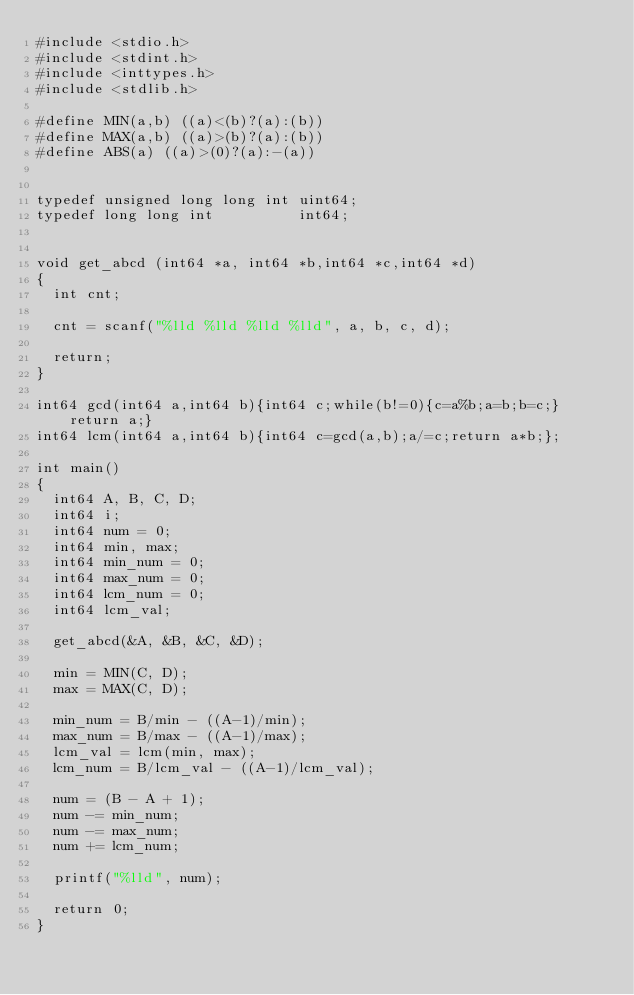<code> <loc_0><loc_0><loc_500><loc_500><_C_>#include <stdio.h>
#include <stdint.h>
#include <inttypes.h>
#include <stdlib.h>

#define MIN(a,b) ((a)<(b)?(a):(b))
#define MAX(a,b) ((a)>(b)?(a):(b))
#define ABS(a) ((a)>(0)?(a):-(a))


typedef unsigned long long int uint64;
typedef long long int          int64;


void get_abcd (int64 *a, int64 *b,int64 *c,int64 *d)
{
  int cnt;
  
  cnt = scanf("%lld %lld %lld %lld", a, b, c, d);

  return;
}

int64 gcd(int64 a,int64 b){int64 c;while(b!=0){c=a%b;a=b;b=c;}return a;}
int64 lcm(int64 a,int64 b){int64 c=gcd(a,b);a/=c;return a*b;};

int main()
{
  int64 A, B, C, D;
  int64 i;
  int64 num = 0;
  int64 min, max;
  int64 min_num = 0;
  int64 max_num = 0;
  int64 lcm_num = 0;
  int64 lcm_val;

  get_abcd(&A, &B, &C, &D);

  min = MIN(C, D);
  max = MAX(C, D);

  min_num = B/min - ((A-1)/min);
  max_num = B/max - ((A-1)/max);
  lcm_val = lcm(min, max);
  lcm_num = B/lcm_val - ((A-1)/lcm_val);

  num = (B - A + 1);
  num -= min_num;
  num -= max_num;
  num += lcm_num;

  printf("%lld", num);

  return 0;
}

</code> 